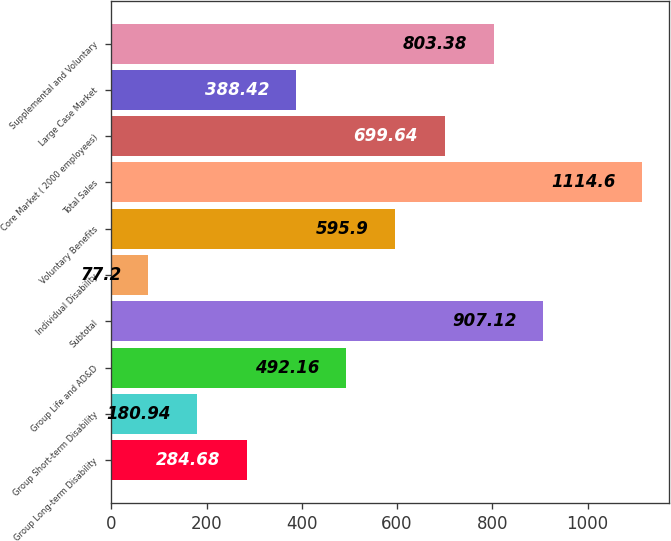<chart> <loc_0><loc_0><loc_500><loc_500><bar_chart><fcel>Group Long-term Disability<fcel>Group Short-term Disability<fcel>Group Life and AD&D<fcel>Subtotal<fcel>Individual Disability<fcel>Voluntary Benefits<fcel>Total Sales<fcel>Core Market ( 2000 employees)<fcel>Large Case Market<fcel>Supplemental and Voluntary<nl><fcel>284.68<fcel>180.94<fcel>492.16<fcel>907.12<fcel>77.2<fcel>595.9<fcel>1114.6<fcel>699.64<fcel>388.42<fcel>803.38<nl></chart> 